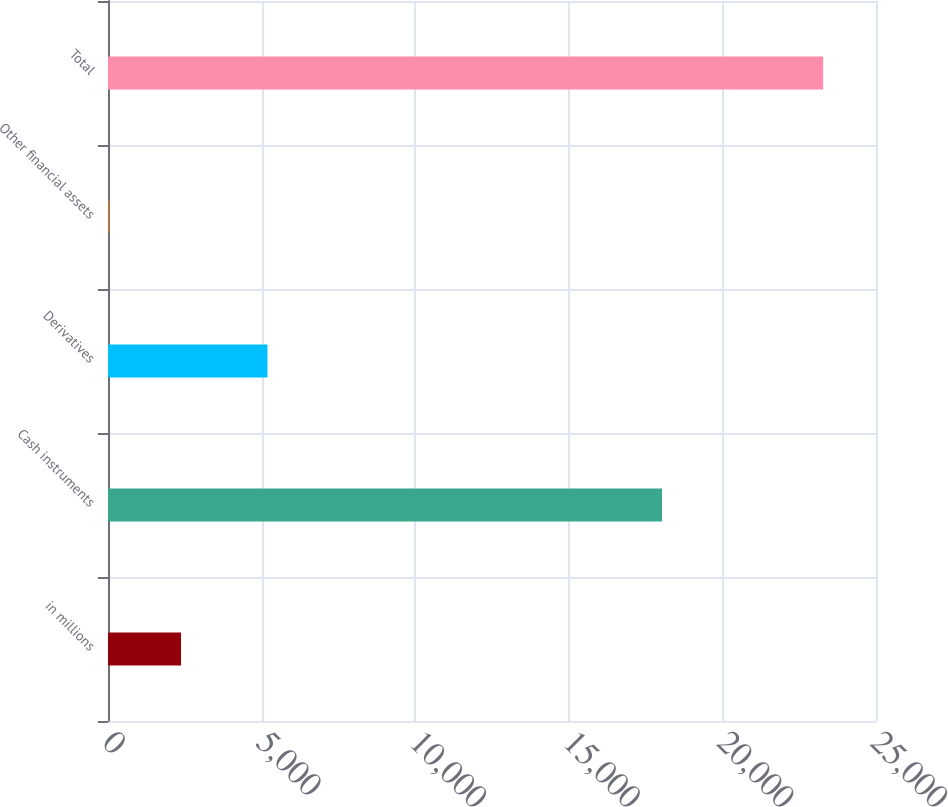Convert chart to OTSL. <chart><loc_0><loc_0><loc_500><loc_500><bar_chart><fcel>in millions<fcel>Cash instruments<fcel>Derivatives<fcel>Other financial assets<fcel>Total<nl><fcel>2377.5<fcel>18035<fcel>5190<fcel>55<fcel>23280<nl></chart> 